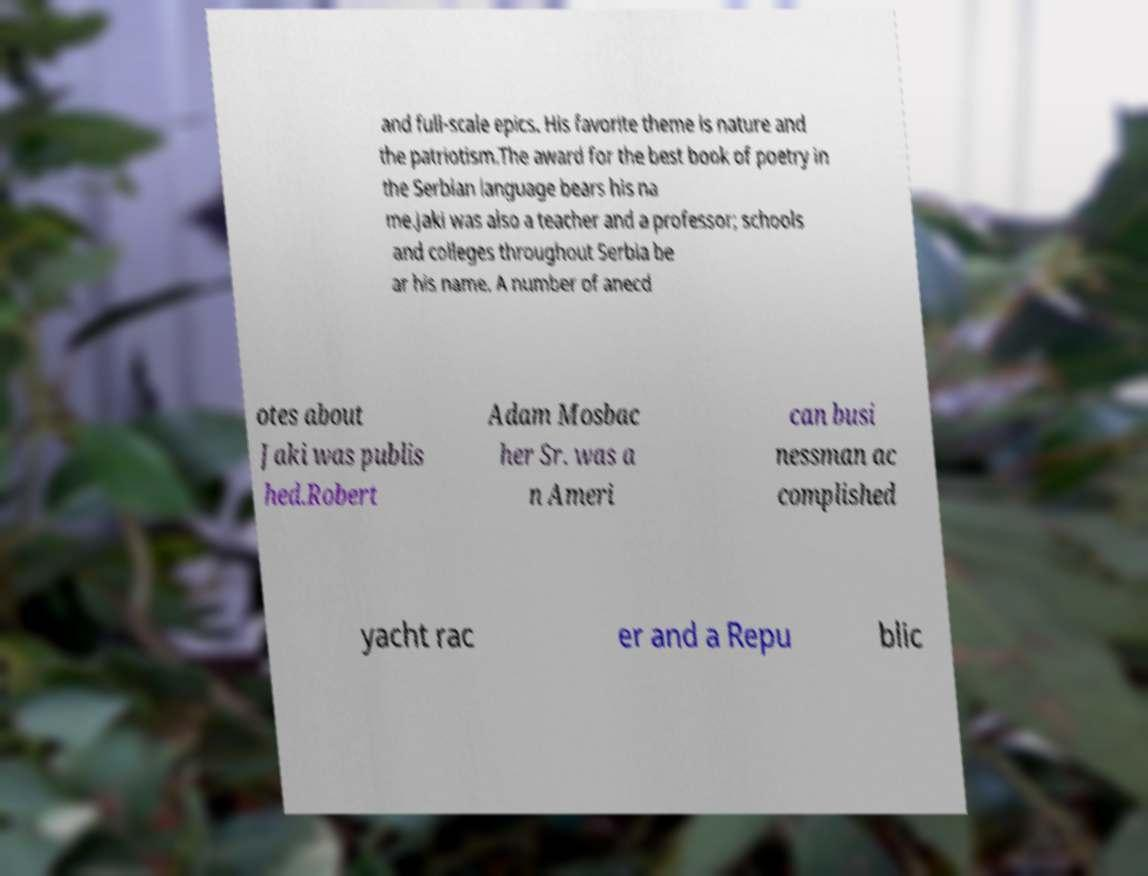There's text embedded in this image that I need extracted. Can you transcribe it verbatim? and full-scale epics. His favorite theme is nature and the patriotism.The award for the best book of poetry in the Serbian language bears his na me.Jaki was also a teacher and a professor; schools and colleges throughout Serbia be ar his name. A number of anecd otes about Jaki was publis hed.Robert Adam Mosbac her Sr. was a n Ameri can busi nessman ac complished yacht rac er and a Repu blic 